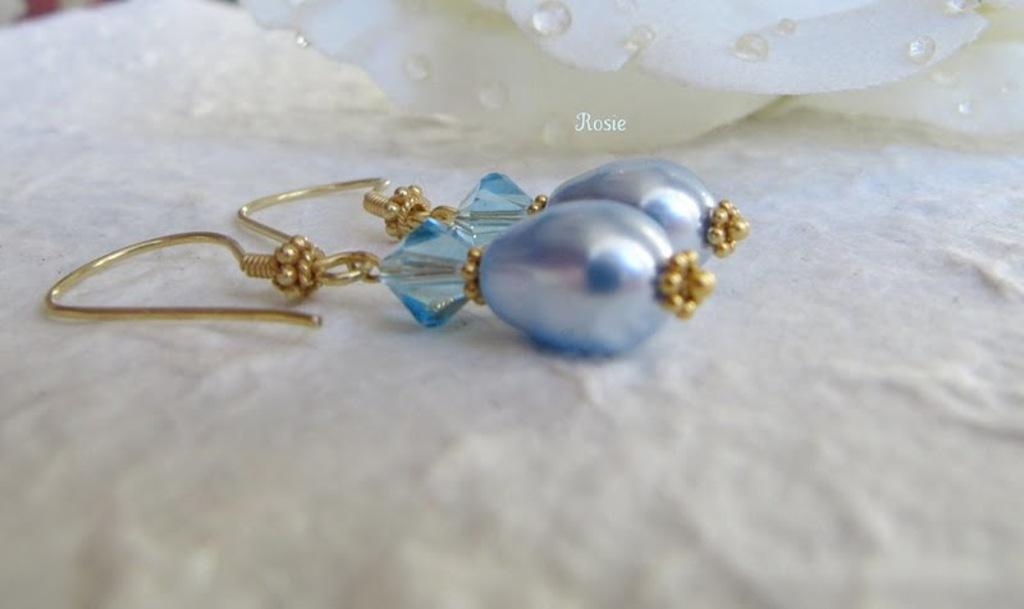What type of jewelry is present in the image? There are earrings in the image. Where are the earrings placed in the image? The earrings are on a white platform. Is there a bridge visible in the image? No, there is no bridge present in the image. What type of exchange is taking place between the earrings in the image? There is no exchange happening between the earrings in the image, as they are simply placed on a white platform. 